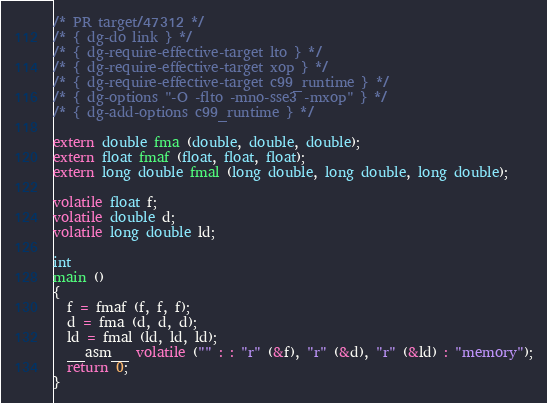Convert code to text. <code><loc_0><loc_0><loc_500><loc_500><_C_>/* PR target/47312 */
/* { dg-do link } */
/* { dg-require-effective-target lto } */
/* { dg-require-effective-target xop } */
/* { dg-require-effective-target c99_runtime } */
/* { dg-options "-O -flto -mno-sse3 -mxop" } */
/* { dg-add-options c99_runtime } */

extern double fma (double, double, double);
extern float fmaf (float, float, float);
extern long double fmal (long double, long double, long double);

volatile float f;
volatile double d;
volatile long double ld;

int
main ()
{
  f = fmaf (f, f, f);
  d = fma (d, d, d);
  ld = fmal (ld, ld, ld);
  __asm__ volatile ("" : : "r" (&f), "r" (&d), "r" (&ld) : "memory");
  return 0;
}
</code> 